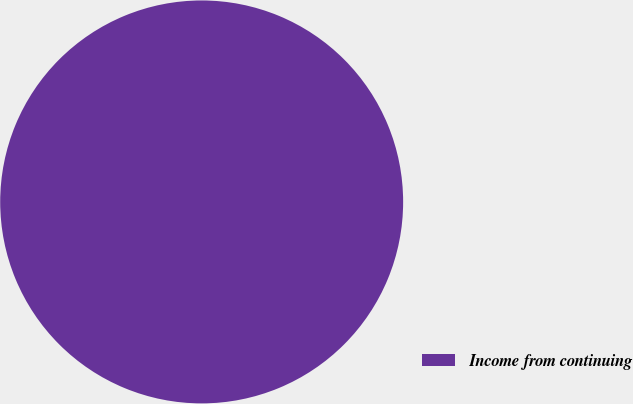Convert chart. <chart><loc_0><loc_0><loc_500><loc_500><pie_chart><fcel>Income from continuing<nl><fcel>100.0%<nl></chart> 